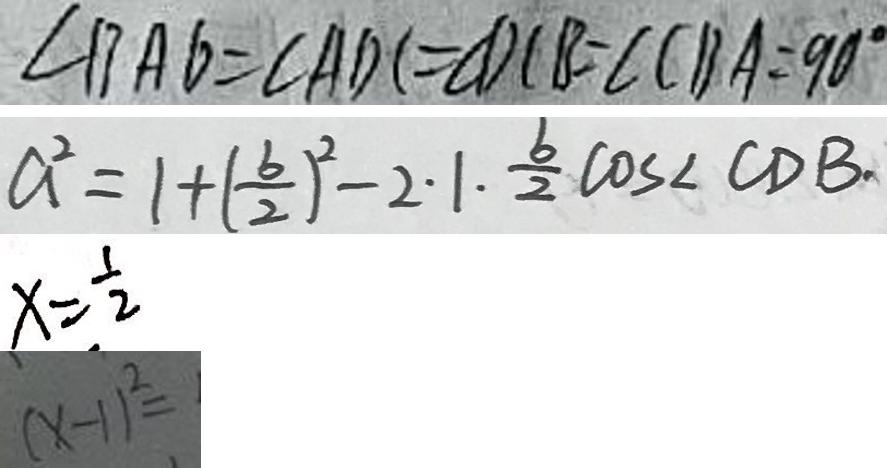Convert formula to latex. <formula><loc_0><loc_0><loc_500><loc_500>\angle B A D = \angle A D C = \angle D C B = \angle C B A = 9 0 ^ { \circ } 
 a ^ { 2 } = 1 + ( \frac { b } { 2 } ) ^ { 2 } - 2 \cdot 1 \cdot \frac { b } { 2 } \cos \angle C D B . 
 x = \frac { 1 } { 2 } 
 ( x - 1 ) ^ { 2 } =</formula> 